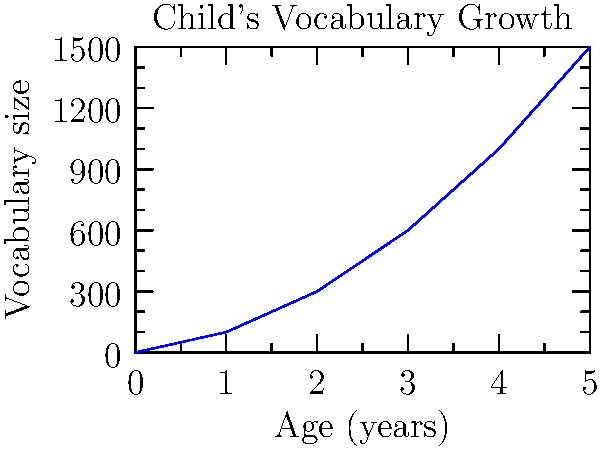The graph shows the growth of a child's vocabulary from birth to age 5. At what age does the child's vocabulary size reach 600 words? To determine the age at which the child's vocabulary reaches 600 words, we need to follow these steps:

1. Observe the y-axis (vocabulary size) and locate the 600-word mark.
2. Draw an imaginary horizontal line from the 600-word mark to intersect with the graph line.
3. From this intersection point, draw an imaginary vertical line down to the x-axis (age).
4. Read the age value where this vertical line meets the x-axis.

Following these steps, we can see that the 600-word mark intersects with the graph line directly above the 3-year mark on the x-axis.

This simple, clean approach to reading the graph aligns with the minimalist perspective while focusing on the important literacy milestone in a child's development.
Answer: 3 years 